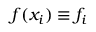Convert formula to latex. <formula><loc_0><loc_0><loc_500><loc_500>f ( x _ { i } ) \equiv f _ { i }</formula> 